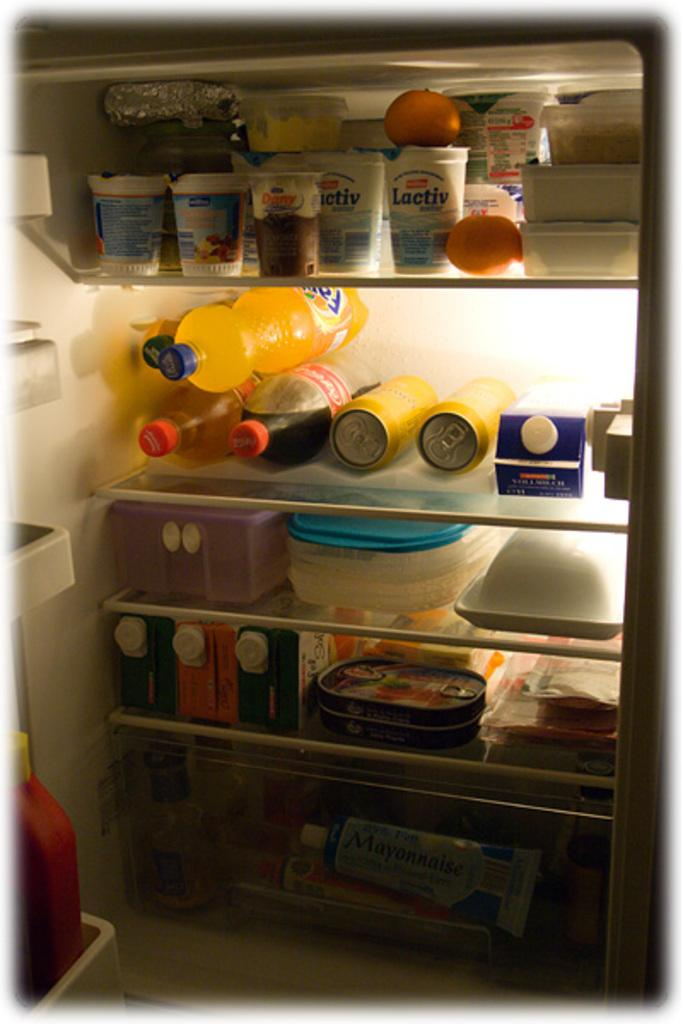What types of containers are visible in the image? There are bottles, tins, and boxes in the image. What other item can be seen in the image? There is aluminium foil in the image. What is the common feature of all the items in the image? All of these items are placed in a refrigerator. Can you describe any other objects in the image? There are other objects in the image, but their specific details are not mentioned in the provided facts. What activity is the neck performing in the image? There is no neck present in the image, so it is not possible to answer that question. 